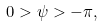Convert formula to latex. <formula><loc_0><loc_0><loc_500><loc_500>0 > \psi > - \pi ,</formula> 